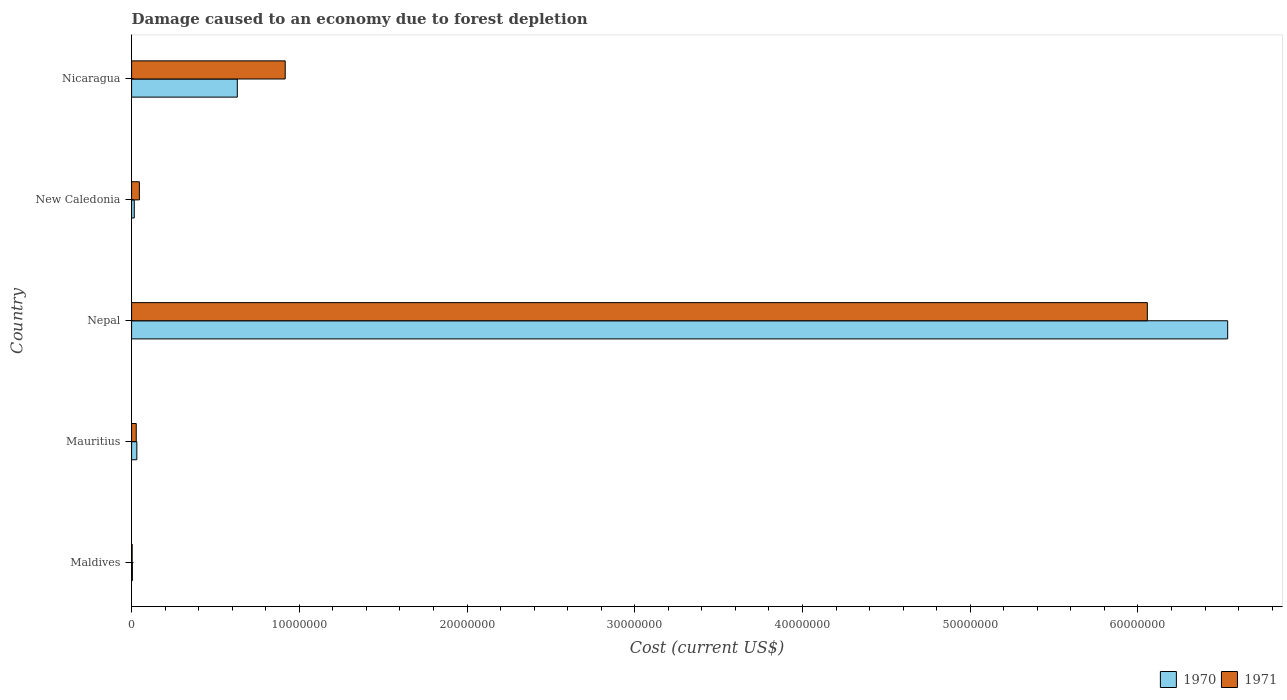How many groups of bars are there?
Your answer should be very brief. 5. Are the number of bars on each tick of the Y-axis equal?
Offer a very short reply. Yes. What is the label of the 4th group of bars from the top?
Keep it short and to the point. Mauritius. In how many cases, is the number of bars for a given country not equal to the number of legend labels?
Keep it short and to the point. 0. What is the cost of damage caused due to forest depletion in 1970 in Nicaragua?
Offer a very short reply. 6.30e+06. Across all countries, what is the maximum cost of damage caused due to forest depletion in 1971?
Ensure brevity in your answer.  6.06e+07. Across all countries, what is the minimum cost of damage caused due to forest depletion in 1971?
Offer a terse response. 3.48e+04. In which country was the cost of damage caused due to forest depletion in 1971 maximum?
Make the answer very short. Nepal. In which country was the cost of damage caused due to forest depletion in 1970 minimum?
Keep it short and to the point. Maldives. What is the total cost of damage caused due to forest depletion in 1970 in the graph?
Give a very brief answer. 7.22e+07. What is the difference between the cost of damage caused due to forest depletion in 1970 in Nepal and that in New Caledonia?
Your response must be concise. 6.52e+07. What is the difference between the cost of damage caused due to forest depletion in 1970 in Nicaragua and the cost of damage caused due to forest depletion in 1971 in Nepal?
Ensure brevity in your answer.  -5.43e+07. What is the average cost of damage caused due to forest depletion in 1971 per country?
Ensure brevity in your answer.  1.41e+07. What is the difference between the cost of damage caused due to forest depletion in 1970 and cost of damage caused due to forest depletion in 1971 in Nicaragua?
Give a very brief answer. -2.86e+06. In how many countries, is the cost of damage caused due to forest depletion in 1970 greater than 26000000 US$?
Ensure brevity in your answer.  1. What is the ratio of the cost of damage caused due to forest depletion in 1971 in Mauritius to that in Nepal?
Provide a short and direct response. 0. What is the difference between the highest and the second highest cost of damage caused due to forest depletion in 1971?
Give a very brief answer. 5.14e+07. What is the difference between the highest and the lowest cost of damage caused due to forest depletion in 1971?
Make the answer very short. 6.05e+07. In how many countries, is the cost of damage caused due to forest depletion in 1971 greater than the average cost of damage caused due to forest depletion in 1971 taken over all countries?
Ensure brevity in your answer.  1. What does the 2nd bar from the top in Nepal represents?
Your response must be concise. 1970. How many bars are there?
Offer a very short reply. 10. How many countries are there in the graph?
Ensure brevity in your answer.  5. Does the graph contain grids?
Keep it short and to the point. No. Where does the legend appear in the graph?
Offer a very short reply. Bottom right. How many legend labels are there?
Your response must be concise. 2. What is the title of the graph?
Ensure brevity in your answer.  Damage caused to an economy due to forest depletion. Does "1961" appear as one of the legend labels in the graph?
Provide a short and direct response. No. What is the label or title of the X-axis?
Provide a short and direct response. Cost (current US$). What is the label or title of the Y-axis?
Provide a succinct answer. Country. What is the Cost (current US$) of 1970 in Maldives?
Provide a succinct answer. 4.86e+04. What is the Cost (current US$) of 1971 in Maldives?
Your answer should be compact. 3.48e+04. What is the Cost (current US$) of 1970 in Mauritius?
Make the answer very short. 3.14e+05. What is the Cost (current US$) in 1971 in Mauritius?
Offer a terse response. 2.78e+05. What is the Cost (current US$) in 1970 in Nepal?
Provide a short and direct response. 6.54e+07. What is the Cost (current US$) in 1971 in Nepal?
Your answer should be very brief. 6.06e+07. What is the Cost (current US$) in 1970 in New Caledonia?
Offer a terse response. 1.60e+05. What is the Cost (current US$) of 1971 in New Caledonia?
Offer a very short reply. 4.65e+05. What is the Cost (current US$) in 1970 in Nicaragua?
Give a very brief answer. 6.30e+06. What is the Cost (current US$) of 1971 in Nicaragua?
Keep it short and to the point. 9.16e+06. Across all countries, what is the maximum Cost (current US$) of 1970?
Your answer should be very brief. 6.54e+07. Across all countries, what is the maximum Cost (current US$) in 1971?
Keep it short and to the point. 6.06e+07. Across all countries, what is the minimum Cost (current US$) of 1970?
Keep it short and to the point. 4.86e+04. Across all countries, what is the minimum Cost (current US$) in 1971?
Provide a short and direct response. 3.48e+04. What is the total Cost (current US$) in 1970 in the graph?
Give a very brief answer. 7.22e+07. What is the total Cost (current US$) in 1971 in the graph?
Your answer should be very brief. 7.05e+07. What is the difference between the Cost (current US$) of 1970 in Maldives and that in Mauritius?
Keep it short and to the point. -2.65e+05. What is the difference between the Cost (current US$) in 1971 in Maldives and that in Mauritius?
Your answer should be compact. -2.44e+05. What is the difference between the Cost (current US$) of 1970 in Maldives and that in Nepal?
Your answer should be compact. -6.53e+07. What is the difference between the Cost (current US$) in 1971 in Maldives and that in Nepal?
Provide a succinct answer. -6.05e+07. What is the difference between the Cost (current US$) in 1970 in Maldives and that in New Caledonia?
Offer a terse response. -1.11e+05. What is the difference between the Cost (current US$) of 1971 in Maldives and that in New Caledonia?
Ensure brevity in your answer.  -4.30e+05. What is the difference between the Cost (current US$) of 1970 in Maldives and that in Nicaragua?
Offer a very short reply. -6.26e+06. What is the difference between the Cost (current US$) in 1971 in Maldives and that in Nicaragua?
Give a very brief answer. -9.12e+06. What is the difference between the Cost (current US$) of 1970 in Mauritius and that in Nepal?
Ensure brevity in your answer.  -6.50e+07. What is the difference between the Cost (current US$) of 1971 in Mauritius and that in Nepal?
Offer a very short reply. -6.03e+07. What is the difference between the Cost (current US$) in 1970 in Mauritius and that in New Caledonia?
Ensure brevity in your answer.  1.54e+05. What is the difference between the Cost (current US$) in 1971 in Mauritius and that in New Caledonia?
Your response must be concise. -1.87e+05. What is the difference between the Cost (current US$) of 1970 in Mauritius and that in Nicaragua?
Give a very brief answer. -5.99e+06. What is the difference between the Cost (current US$) in 1971 in Mauritius and that in Nicaragua?
Offer a terse response. -8.88e+06. What is the difference between the Cost (current US$) in 1970 in Nepal and that in New Caledonia?
Your answer should be compact. 6.52e+07. What is the difference between the Cost (current US$) of 1971 in Nepal and that in New Caledonia?
Offer a terse response. 6.01e+07. What is the difference between the Cost (current US$) of 1970 in Nepal and that in Nicaragua?
Offer a very short reply. 5.90e+07. What is the difference between the Cost (current US$) of 1971 in Nepal and that in Nicaragua?
Your answer should be compact. 5.14e+07. What is the difference between the Cost (current US$) in 1970 in New Caledonia and that in Nicaragua?
Give a very brief answer. -6.14e+06. What is the difference between the Cost (current US$) in 1971 in New Caledonia and that in Nicaragua?
Keep it short and to the point. -8.69e+06. What is the difference between the Cost (current US$) of 1970 in Maldives and the Cost (current US$) of 1971 in Mauritius?
Your response must be concise. -2.30e+05. What is the difference between the Cost (current US$) in 1970 in Maldives and the Cost (current US$) in 1971 in Nepal?
Offer a very short reply. -6.05e+07. What is the difference between the Cost (current US$) in 1970 in Maldives and the Cost (current US$) in 1971 in New Caledonia?
Provide a short and direct response. -4.16e+05. What is the difference between the Cost (current US$) of 1970 in Maldives and the Cost (current US$) of 1971 in Nicaragua?
Give a very brief answer. -9.11e+06. What is the difference between the Cost (current US$) of 1970 in Mauritius and the Cost (current US$) of 1971 in Nepal?
Your answer should be compact. -6.02e+07. What is the difference between the Cost (current US$) of 1970 in Mauritius and the Cost (current US$) of 1971 in New Caledonia?
Provide a succinct answer. -1.52e+05. What is the difference between the Cost (current US$) of 1970 in Mauritius and the Cost (current US$) of 1971 in Nicaragua?
Provide a short and direct response. -8.85e+06. What is the difference between the Cost (current US$) of 1970 in Nepal and the Cost (current US$) of 1971 in New Caledonia?
Make the answer very short. 6.49e+07. What is the difference between the Cost (current US$) in 1970 in Nepal and the Cost (current US$) in 1971 in Nicaragua?
Provide a succinct answer. 5.62e+07. What is the difference between the Cost (current US$) of 1970 in New Caledonia and the Cost (current US$) of 1971 in Nicaragua?
Keep it short and to the point. -9.00e+06. What is the average Cost (current US$) in 1970 per country?
Make the answer very short. 1.44e+07. What is the average Cost (current US$) in 1971 per country?
Offer a very short reply. 1.41e+07. What is the difference between the Cost (current US$) of 1970 and Cost (current US$) of 1971 in Maldives?
Offer a very short reply. 1.39e+04. What is the difference between the Cost (current US$) of 1970 and Cost (current US$) of 1971 in Mauritius?
Your response must be concise. 3.52e+04. What is the difference between the Cost (current US$) of 1970 and Cost (current US$) of 1971 in Nepal?
Ensure brevity in your answer.  4.79e+06. What is the difference between the Cost (current US$) of 1970 and Cost (current US$) of 1971 in New Caledonia?
Offer a very short reply. -3.05e+05. What is the difference between the Cost (current US$) of 1970 and Cost (current US$) of 1971 in Nicaragua?
Ensure brevity in your answer.  -2.86e+06. What is the ratio of the Cost (current US$) of 1970 in Maldives to that in Mauritius?
Provide a succinct answer. 0.16. What is the ratio of the Cost (current US$) of 1970 in Maldives to that in Nepal?
Offer a very short reply. 0. What is the ratio of the Cost (current US$) in 1971 in Maldives to that in Nepal?
Keep it short and to the point. 0. What is the ratio of the Cost (current US$) of 1970 in Maldives to that in New Caledonia?
Provide a short and direct response. 0.3. What is the ratio of the Cost (current US$) of 1971 in Maldives to that in New Caledonia?
Your response must be concise. 0.07. What is the ratio of the Cost (current US$) in 1970 in Maldives to that in Nicaragua?
Keep it short and to the point. 0.01. What is the ratio of the Cost (current US$) of 1971 in Maldives to that in Nicaragua?
Give a very brief answer. 0. What is the ratio of the Cost (current US$) in 1970 in Mauritius to that in Nepal?
Your response must be concise. 0. What is the ratio of the Cost (current US$) of 1971 in Mauritius to that in Nepal?
Your response must be concise. 0. What is the ratio of the Cost (current US$) in 1970 in Mauritius to that in New Caledonia?
Give a very brief answer. 1.96. What is the ratio of the Cost (current US$) in 1971 in Mauritius to that in New Caledonia?
Offer a terse response. 0.6. What is the ratio of the Cost (current US$) in 1970 in Mauritius to that in Nicaragua?
Make the answer very short. 0.05. What is the ratio of the Cost (current US$) of 1971 in Mauritius to that in Nicaragua?
Your answer should be compact. 0.03. What is the ratio of the Cost (current US$) of 1970 in Nepal to that in New Caledonia?
Make the answer very short. 409.45. What is the ratio of the Cost (current US$) of 1971 in Nepal to that in New Caledonia?
Your answer should be compact. 130.21. What is the ratio of the Cost (current US$) in 1970 in Nepal to that in Nicaragua?
Give a very brief answer. 10.37. What is the ratio of the Cost (current US$) of 1971 in Nepal to that in Nicaragua?
Give a very brief answer. 6.61. What is the ratio of the Cost (current US$) in 1970 in New Caledonia to that in Nicaragua?
Your answer should be very brief. 0.03. What is the ratio of the Cost (current US$) in 1971 in New Caledonia to that in Nicaragua?
Ensure brevity in your answer.  0.05. What is the difference between the highest and the second highest Cost (current US$) in 1970?
Your answer should be very brief. 5.90e+07. What is the difference between the highest and the second highest Cost (current US$) of 1971?
Ensure brevity in your answer.  5.14e+07. What is the difference between the highest and the lowest Cost (current US$) in 1970?
Make the answer very short. 6.53e+07. What is the difference between the highest and the lowest Cost (current US$) in 1971?
Provide a succinct answer. 6.05e+07. 